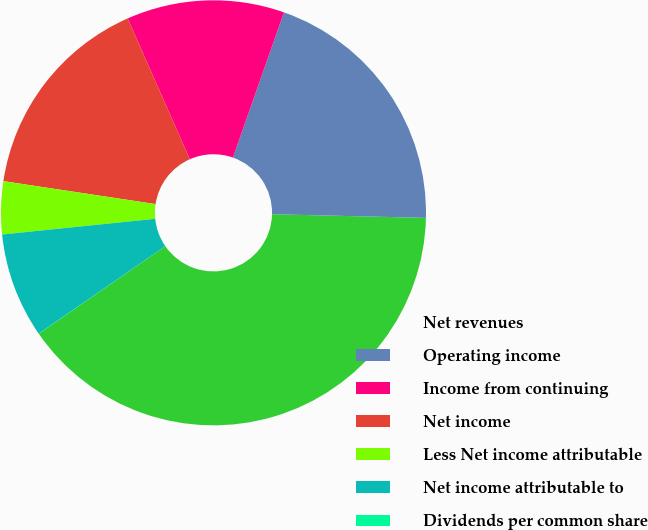Convert chart. <chart><loc_0><loc_0><loc_500><loc_500><pie_chart><fcel>Net revenues<fcel>Operating income<fcel>Income from continuing<fcel>Net income<fcel>Less Net income attributable<fcel>Net income attributable to<fcel>Dividends per common share<nl><fcel>39.99%<fcel>20.0%<fcel>12.0%<fcel>16.0%<fcel>4.01%<fcel>8.0%<fcel>0.01%<nl></chart> 